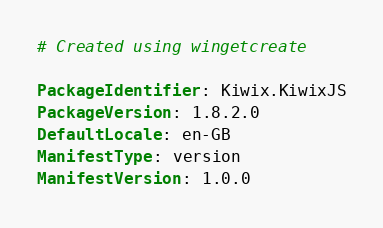Convert code to text. <code><loc_0><loc_0><loc_500><loc_500><_YAML_># Created using wingetcreate

PackageIdentifier: Kiwix.KiwixJS
PackageVersion: 1.8.2.0
DefaultLocale: en-GB
ManifestType: version
ManifestVersion: 1.0.0
</code> 